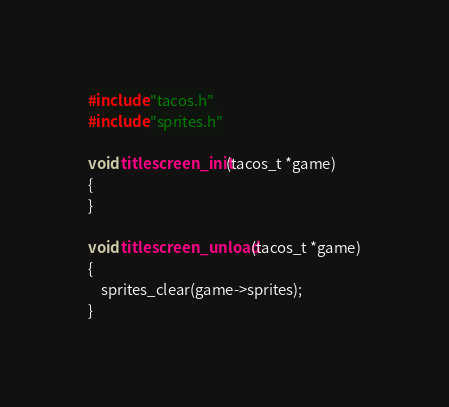Convert code to text. <code><loc_0><loc_0><loc_500><loc_500><_C_>#include "tacos.h"
#include "sprites.h"

void titlescreen_init(tacos_t *game)
{
}

void titlescreen_unload(tacos_t *game)
{
	sprites_clear(game->sprites);
}
</code> 